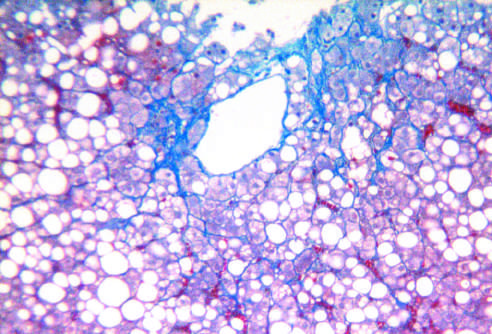s some fibrosis present in a characteristic perisinusoidal chicken wire fence pattern (masson trichrome stain)?
Answer the question using a single word or phrase. Yes 